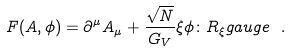Convert formula to latex. <formula><loc_0><loc_0><loc_500><loc_500>F ( A , \phi ) = \partial ^ { \mu } A _ { \mu } + \frac { \sqrt { N } } { G _ { V } } \xi \phi \colon R _ { \xi } g a u g e \ .</formula> 